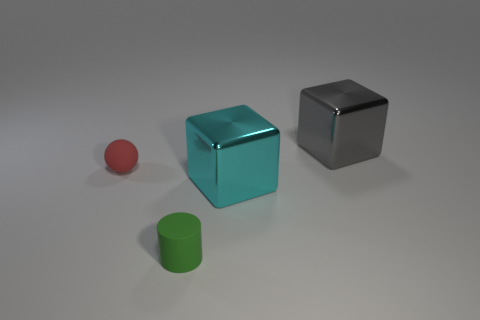Add 4 small yellow rubber balls. How many objects exist? 8 Subtract all balls. How many objects are left? 3 Subtract all tiny purple cubes. Subtract all metal objects. How many objects are left? 2 Add 2 small objects. How many small objects are left? 4 Add 1 big cyan metal things. How many big cyan metal things exist? 2 Subtract 1 green cylinders. How many objects are left? 3 